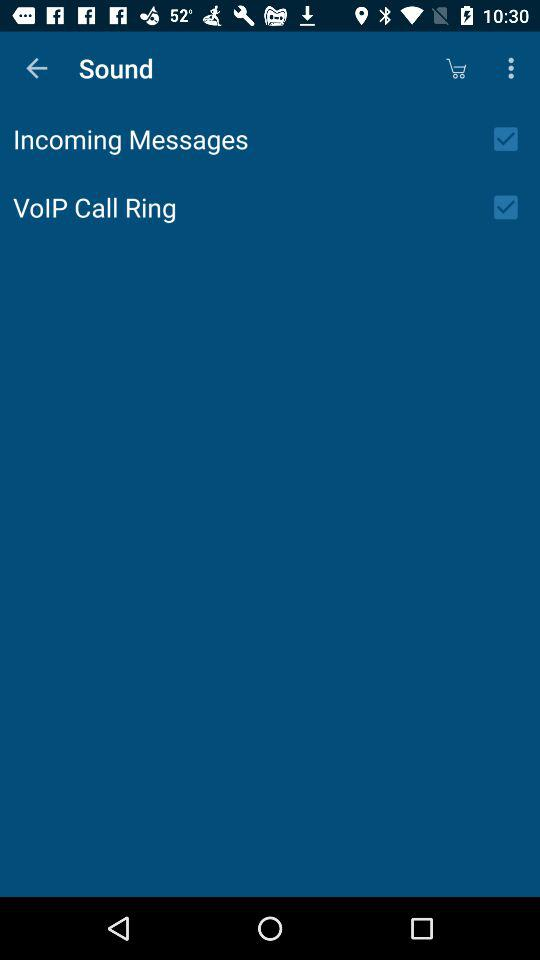What's the status of the "VolP Call Ring"? The status is on. 